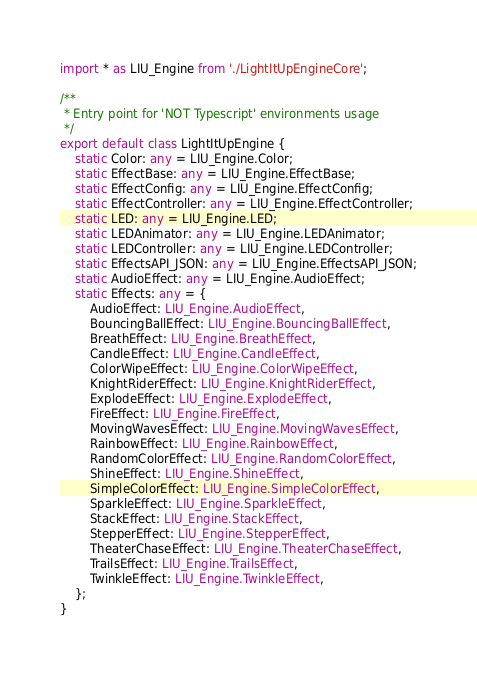Convert code to text. <code><loc_0><loc_0><loc_500><loc_500><_TypeScript_>import * as LIU_Engine from './LightItUpEngineCore';

/**
 * Entry point for 'NOT Typescript' environments usage
 */
export default class LightItUpEngine {
    static Color: any = LIU_Engine.Color;
    static EffectBase: any = LIU_Engine.EffectBase;
    static EffectConfig: any = LIU_Engine.EffectConfig;
    static EffectController: any = LIU_Engine.EffectController;
    static LED: any = LIU_Engine.LED;
    static LEDAnimator: any = LIU_Engine.LEDAnimator;
    static LEDController: any = LIU_Engine.LEDController;
    static EffectsAPI_JSON: any = LIU_Engine.EffectsAPI_JSON;
    static AudioEffect: any = LIU_Engine.AudioEffect;
    static Effects: any = {
        AudioEffect: LIU_Engine.AudioEffect,
        BouncingBallEffect: LIU_Engine.BouncingBallEffect,
        BreathEffect: LIU_Engine.BreathEffect,
        CandleEffect: LIU_Engine.CandleEffect,
        ColorWipeEffect: LIU_Engine.ColorWipeEffect,
        KnightRiderEffect: LIU_Engine.KnightRiderEffect,
        ExplodeEffect: LIU_Engine.ExplodeEffect,
        FireEffect: LIU_Engine.FireEffect,
        MovingWavesEffect: LIU_Engine.MovingWavesEffect,
        RainbowEffect: LIU_Engine.RainbowEffect,
        RandomColorEffect: LIU_Engine.RandomColorEffect,
        ShineEffect: LIU_Engine.ShineEffect,
        SimpleColorEffect: LIU_Engine.SimpleColorEffect,
        SparkleEffect: LIU_Engine.SparkleEffect,
        StackEffect: LIU_Engine.StackEffect,
        StepperEffect: LIU_Engine.StepperEffect,
        TheaterChaseEffect: LIU_Engine.TheaterChaseEffect,
        TrailsEffect: LIU_Engine.TrailsEffect,
        TwinkleEffect: LIU_Engine.TwinkleEffect,
    };
}
</code> 